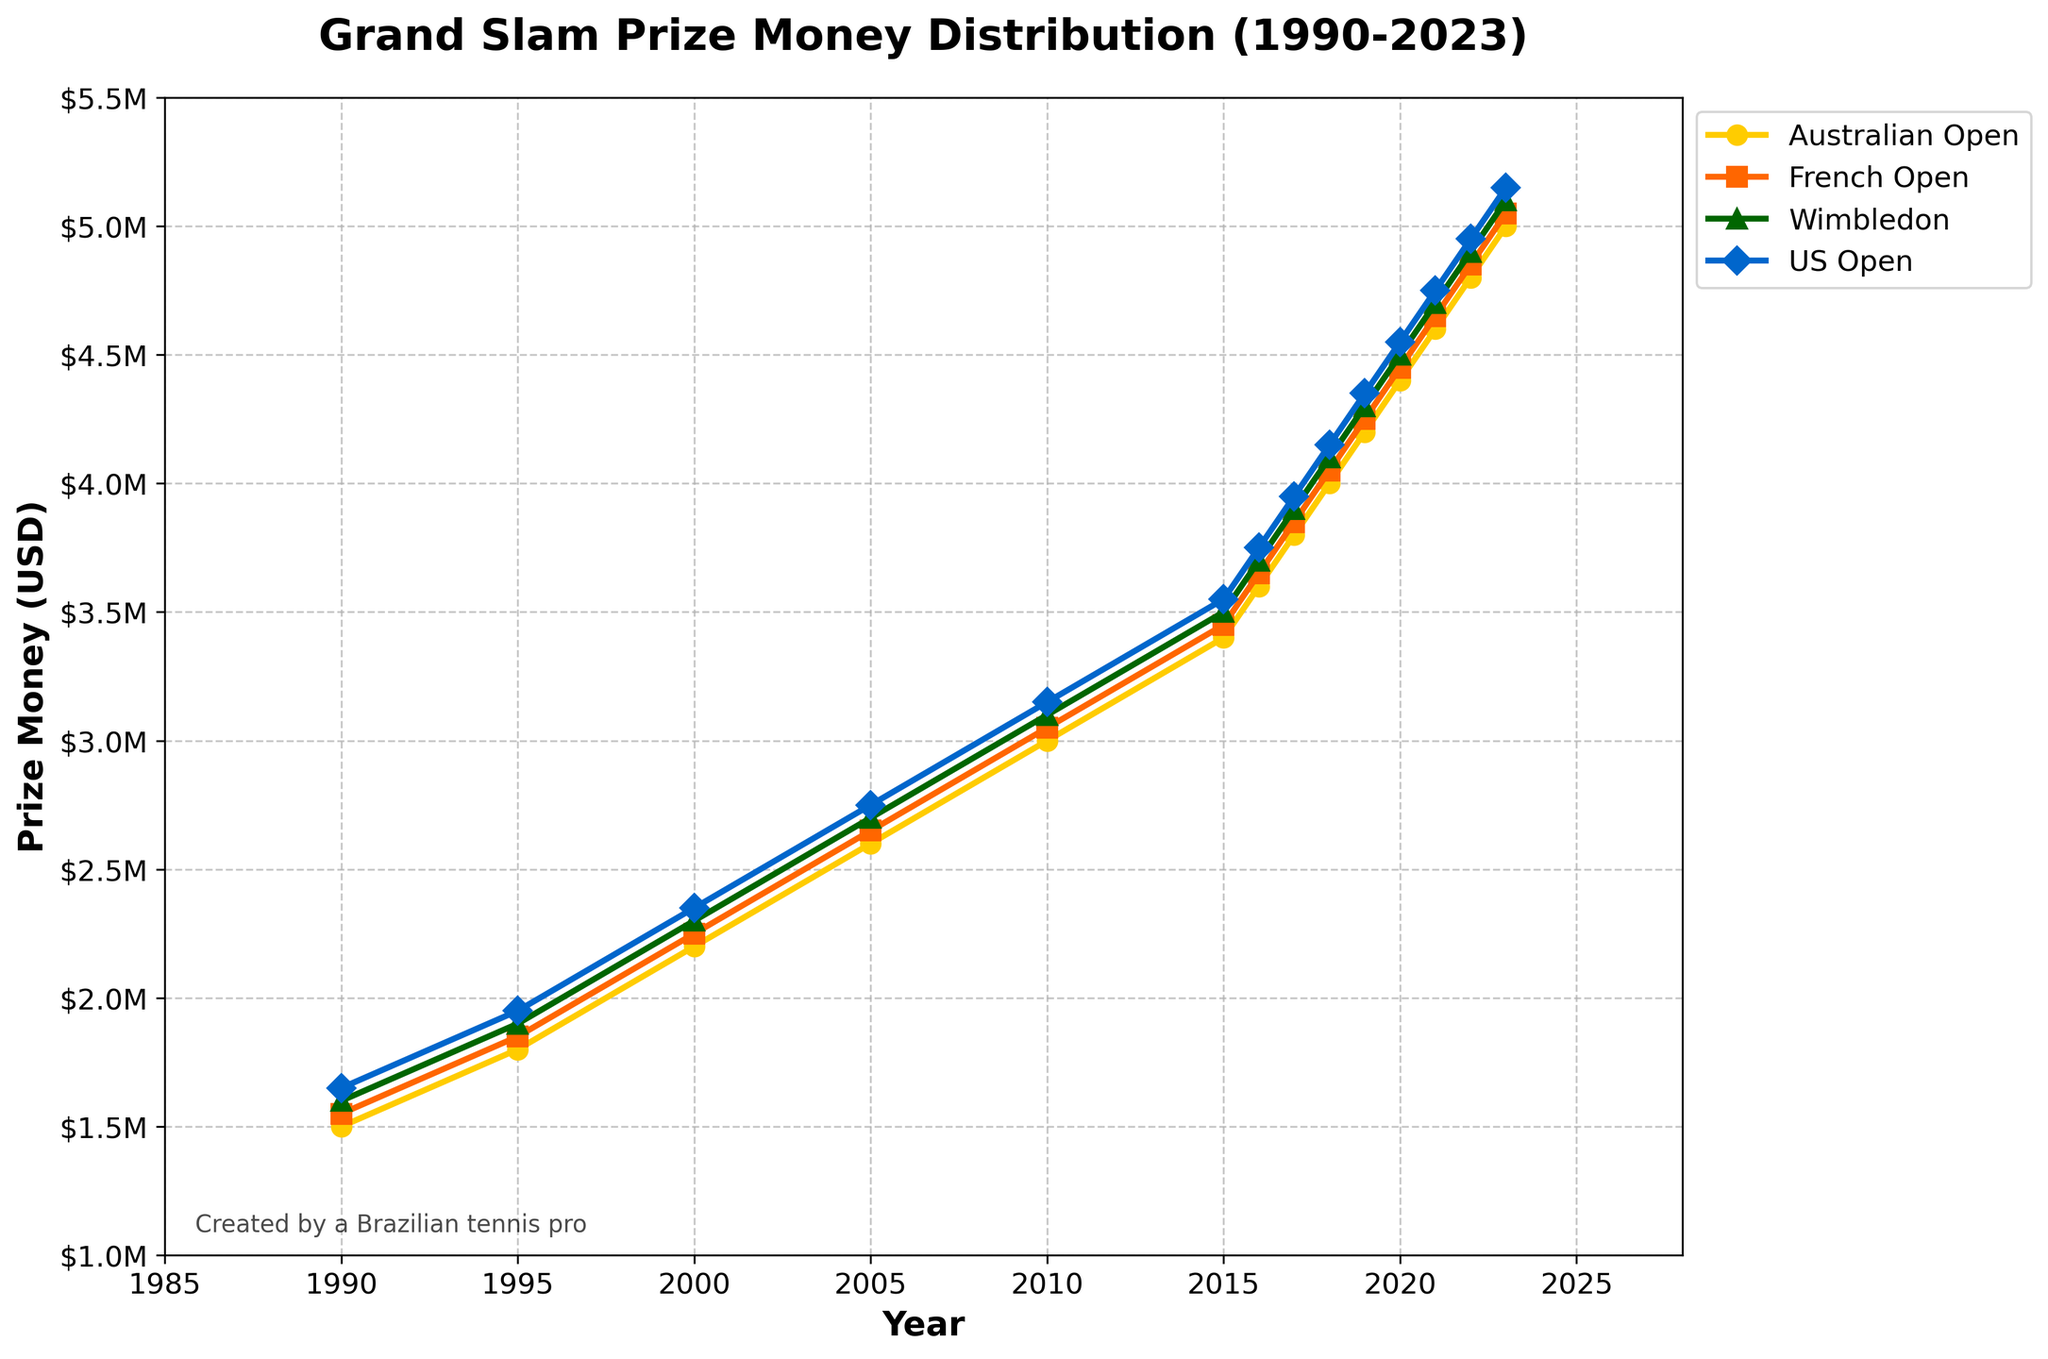Which Grand Slam tournament had the highest prize money in 2023? Look at the 2023 data points on the right edge of the plot. The highest among them corresponds to the US Open.
Answer: US Open Which year saw the first increase in prize money for the Australian Open over $2,000,000? Trace the line representing the Australian Open and find the first year the prize money surpasses $2,000,000. This occurs in 2000.
Answer: 2000 By how much did the prize money for Wimbledon increase from 1990 to 2023? Identify the prize money for Wimbledon in 1990 and 2023 and subtract the former from the latter: $5,100,000 (2023) - $1,600,000 (1990).
Answer: $3,500,000 What is the average prize money for the US Open from 2000 to 2023? Add the prize money for each year from 2000 to 2023 and divide by the number of years: ($2,350,000 + $2,750,000 + ... + $5,150,000)/12.
Answer: $3,825,000 Which tournament's prize money was the last to exceed $4,000,000? Examine the plot for when each line crosses the $4,000,000 mark. The Australian Open reached it last, in 2018.
Answer: Australian Open In which year did the prize money for the French Open surpass $4,000,000? Locate the point where the French Open line exceeds $4,000,000. This occurs in 2018.
Answer: 2018 How much more was the prize money for the US Open than the French Open in 2022? Find the values for 2022 for the French Open ($4,850,000) and the US Open ($4,950,000), then calculate the difference: $4,950,000 - $4,850,000.
Answer: $100,000 How did the prize money trend for Wimbledon compare to the US Open between 1990 and 2010? Examine the lines representing Wimbledon and the US Open between 1990 and 2010. Both show a consistent upward trend, with the US Open consistently having a slightly higher prize money than Wimbledon.
Answer: Consistent upward, with US Open slightly higher Which tournament had the most significant increase in prize money between 1990 and 1995? Compare the increases for each tournament between 1990 and 1995. The US Open had the largest increase from $1,650,000 to $1,950,000.
Answer: US Open 